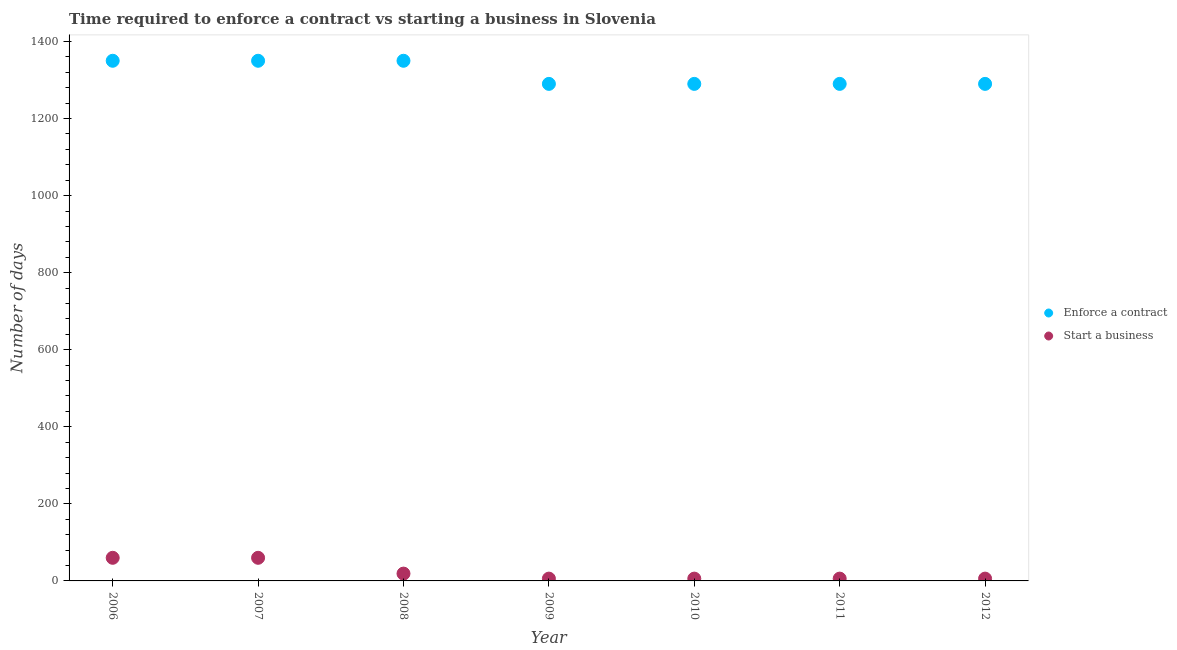How many different coloured dotlines are there?
Your answer should be compact. 2. What is the number of days to enforece a contract in 2010?
Provide a short and direct response. 1290. Across all years, what is the maximum number of days to enforece a contract?
Make the answer very short. 1350. Across all years, what is the minimum number of days to start a business?
Offer a very short reply. 6. In which year was the number of days to enforece a contract maximum?
Make the answer very short. 2006. In which year was the number of days to start a business minimum?
Offer a terse response. 2009. What is the total number of days to start a business in the graph?
Keep it short and to the point. 163. What is the difference between the number of days to enforece a contract in 2011 and the number of days to start a business in 2012?
Your response must be concise. 1284. What is the average number of days to start a business per year?
Your answer should be very brief. 23.29. In the year 2010, what is the difference between the number of days to enforece a contract and number of days to start a business?
Keep it short and to the point. 1284. In how many years, is the number of days to start a business greater than 360 days?
Provide a short and direct response. 0. What is the ratio of the number of days to enforece a contract in 2007 to that in 2011?
Give a very brief answer. 1.05. Is the number of days to enforece a contract in 2010 less than that in 2011?
Your answer should be compact. No. What is the difference between the highest and the second highest number of days to enforece a contract?
Offer a terse response. 0. What is the difference between the highest and the lowest number of days to enforece a contract?
Keep it short and to the point. 60. Does the number of days to enforece a contract monotonically increase over the years?
Offer a terse response. No. Is the number of days to enforece a contract strictly less than the number of days to start a business over the years?
Provide a succinct answer. No. What is the difference between two consecutive major ticks on the Y-axis?
Your response must be concise. 200. Are the values on the major ticks of Y-axis written in scientific E-notation?
Give a very brief answer. No. Does the graph contain any zero values?
Provide a short and direct response. No. Where does the legend appear in the graph?
Your response must be concise. Center right. What is the title of the graph?
Offer a very short reply. Time required to enforce a contract vs starting a business in Slovenia. What is the label or title of the X-axis?
Give a very brief answer. Year. What is the label or title of the Y-axis?
Offer a very short reply. Number of days. What is the Number of days in Enforce a contract in 2006?
Your answer should be very brief. 1350. What is the Number of days in Start a business in 2006?
Provide a succinct answer. 60. What is the Number of days in Enforce a contract in 2007?
Provide a short and direct response. 1350. What is the Number of days of Start a business in 2007?
Your response must be concise. 60. What is the Number of days in Enforce a contract in 2008?
Your answer should be compact. 1350. What is the Number of days of Enforce a contract in 2009?
Your answer should be very brief. 1290. What is the Number of days of Start a business in 2009?
Your answer should be very brief. 6. What is the Number of days in Enforce a contract in 2010?
Ensure brevity in your answer.  1290. What is the Number of days of Start a business in 2010?
Your answer should be very brief. 6. What is the Number of days in Enforce a contract in 2011?
Keep it short and to the point. 1290. What is the Number of days in Start a business in 2011?
Keep it short and to the point. 6. What is the Number of days of Enforce a contract in 2012?
Make the answer very short. 1290. What is the Number of days in Start a business in 2012?
Keep it short and to the point. 6. Across all years, what is the maximum Number of days of Enforce a contract?
Provide a succinct answer. 1350. Across all years, what is the maximum Number of days of Start a business?
Give a very brief answer. 60. Across all years, what is the minimum Number of days in Enforce a contract?
Your answer should be very brief. 1290. Across all years, what is the minimum Number of days of Start a business?
Ensure brevity in your answer.  6. What is the total Number of days in Enforce a contract in the graph?
Your answer should be very brief. 9210. What is the total Number of days of Start a business in the graph?
Keep it short and to the point. 163. What is the difference between the Number of days in Enforce a contract in 2006 and that in 2008?
Your response must be concise. 0. What is the difference between the Number of days of Start a business in 2006 and that in 2008?
Offer a very short reply. 41. What is the difference between the Number of days of Enforce a contract in 2006 and that in 2009?
Give a very brief answer. 60. What is the difference between the Number of days in Enforce a contract in 2006 and that in 2010?
Give a very brief answer. 60. What is the difference between the Number of days in Start a business in 2006 and that in 2012?
Keep it short and to the point. 54. What is the difference between the Number of days in Start a business in 2007 and that in 2008?
Offer a terse response. 41. What is the difference between the Number of days of Start a business in 2007 and that in 2009?
Provide a succinct answer. 54. What is the difference between the Number of days in Start a business in 2007 and that in 2011?
Provide a succinct answer. 54. What is the difference between the Number of days in Start a business in 2007 and that in 2012?
Give a very brief answer. 54. What is the difference between the Number of days in Enforce a contract in 2008 and that in 2009?
Make the answer very short. 60. What is the difference between the Number of days in Start a business in 2008 and that in 2011?
Keep it short and to the point. 13. What is the difference between the Number of days of Enforce a contract in 2008 and that in 2012?
Provide a succinct answer. 60. What is the difference between the Number of days in Start a business in 2008 and that in 2012?
Provide a short and direct response. 13. What is the difference between the Number of days in Enforce a contract in 2009 and that in 2010?
Ensure brevity in your answer.  0. What is the difference between the Number of days of Start a business in 2009 and that in 2011?
Keep it short and to the point. 0. What is the difference between the Number of days of Start a business in 2009 and that in 2012?
Your answer should be compact. 0. What is the difference between the Number of days in Start a business in 2010 and that in 2011?
Provide a succinct answer. 0. What is the difference between the Number of days of Enforce a contract in 2010 and that in 2012?
Give a very brief answer. 0. What is the difference between the Number of days in Enforce a contract in 2011 and that in 2012?
Ensure brevity in your answer.  0. What is the difference between the Number of days in Enforce a contract in 2006 and the Number of days in Start a business in 2007?
Make the answer very short. 1290. What is the difference between the Number of days of Enforce a contract in 2006 and the Number of days of Start a business in 2008?
Your answer should be compact. 1331. What is the difference between the Number of days of Enforce a contract in 2006 and the Number of days of Start a business in 2009?
Give a very brief answer. 1344. What is the difference between the Number of days in Enforce a contract in 2006 and the Number of days in Start a business in 2010?
Offer a very short reply. 1344. What is the difference between the Number of days in Enforce a contract in 2006 and the Number of days in Start a business in 2011?
Keep it short and to the point. 1344. What is the difference between the Number of days of Enforce a contract in 2006 and the Number of days of Start a business in 2012?
Offer a terse response. 1344. What is the difference between the Number of days of Enforce a contract in 2007 and the Number of days of Start a business in 2008?
Offer a terse response. 1331. What is the difference between the Number of days of Enforce a contract in 2007 and the Number of days of Start a business in 2009?
Provide a short and direct response. 1344. What is the difference between the Number of days in Enforce a contract in 2007 and the Number of days in Start a business in 2010?
Provide a short and direct response. 1344. What is the difference between the Number of days of Enforce a contract in 2007 and the Number of days of Start a business in 2011?
Provide a succinct answer. 1344. What is the difference between the Number of days in Enforce a contract in 2007 and the Number of days in Start a business in 2012?
Your response must be concise. 1344. What is the difference between the Number of days in Enforce a contract in 2008 and the Number of days in Start a business in 2009?
Make the answer very short. 1344. What is the difference between the Number of days of Enforce a contract in 2008 and the Number of days of Start a business in 2010?
Provide a short and direct response. 1344. What is the difference between the Number of days in Enforce a contract in 2008 and the Number of days in Start a business in 2011?
Give a very brief answer. 1344. What is the difference between the Number of days of Enforce a contract in 2008 and the Number of days of Start a business in 2012?
Your response must be concise. 1344. What is the difference between the Number of days in Enforce a contract in 2009 and the Number of days in Start a business in 2010?
Offer a terse response. 1284. What is the difference between the Number of days of Enforce a contract in 2009 and the Number of days of Start a business in 2011?
Provide a succinct answer. 1284. What is the difference between the Number of days in Enforce a contract in 2009 and the Number of days in Start a business in 2012?
Your answer should be very brief. 1284. What is the difference between the Number of days of Enforce a contract in 2010 and the Number of days of Start a business in 2011?
Give a very brief answer. 1284. What is the difference between the Number of days of Enforce a contract in 2010 and the Number of days of Start a business in 2012?
Give a very brief answer. 1284. What is the difference between the Number of days in Enforce a contract in 2011 and the Number of days in Start a business in 2012?
Provide a succinct answer. 1284. What is the average Number of days in Enforce a contract per year?
Make the answer very short. 1315.71. What is the average Number of days of Start a business per year?
Give a very brief answer. 23.29. In the year 2006, what is the difference between the Number of days in Enforce a contract and Number of days in Start a business?
Provide a short and direct response. 1290. In the year 2007, what is the difference between the Number of days in Enforce a contract and Number of days in Start a business?
Keep it short and to the point. 1290. In the year 2008, what is the difference between the Number of days of Enforce a contract and Number of days of Start a business?
Offer a terse response. 1331. In the year 2009, what is the difference between the Number of days of Enforce a contract and Number of days of Start a business?
Provide a succinct answer. 1284. In the year 2010, what is the difference between the Number of days of Enforce a contract and Number of days of Start a business?
Make the answer very short. 1284. In the year 2011, what is the difference between the Number of days in Enforce a contract and Number of days in Start a business?
Your response must be concise. 1284. In the year 2012, what is the difference between the Number of days in Enforce a contract and Number of days in Start a business?
Offer a very short reply. 1284. What is the ratio of the Number of days in Start a business in 2006 to that in 2007?
Give a very brief answer. 1. What is the ratio of the Number of days in Start a business in 2006 to that in 2008?
Keep it short and to the point. 3.16. What is the ratio of the Number of days of Enforce a contract in 2006 to that in 2009?
Offer a very short reply. 1.05. What is the ratio of the Number of days in Enforce a contract in 2006 to that in 2010?
Your response must be concise. 1.05. What is the ratio of the Number of days in Enforce a contract in 2006 to that in 2011?
Give a very brief answer. 1.05. What is the ratio of the Number of days of Start a business in 2006 to that in 2011?
Provide a succinct answer. 10. What is the ratio of the Number of days of Enforce a contract in 2006 to that in 2012?
Your answer should be compact. 1.05. What is the ratio of the Number of days in Start a business in 2006 to that in 2012?
Give a very brief answer. 10. What is the ratio of the Number of days in Start a business in 2007 to that in 2008?
Make the answer very short. 3.16. What is the ratio of the Number of days in Enforce a contract in 2007 to that in 2009?
Your answer should be very brief. 1.05. What is the ratio of the Number of days in Enforce a contract in 2007 to that in 2010?
Keep it short and to the point. 1.05. What is the ratio of the Number of days of Enforce a contract in 2007 to that in 2011?
Offer a very short reply. 1.05. What is the ratio of the Number of days of Start a business in 2007 to that in 2011?
Make the answer very short. 10. What is the ratio of the Number of days of Enforce a contract in 2007 to that in 2012?
Provide a short and direct response. 1.05. What is the ratio of the Number of days in Start a business in 2007 to that in 2012?
Offer a terse response. 10. What is the ratio of the Number of days in Enforce a contract in 2008 to that in 2009?
Offer a very short reply. 1.05. What is the ratio of the Number of days in Start a business in 2008 to that in 2009?
Your response must be concise. 3.17. What is the ratio of the Number of days of Enforce a contract in 2008 to that in 2010?
Your response must be concise. 1.05. What is the ratio of the Number of days in Start a business in 2008 to that in 2010?
Give a very brief answer. 3.17. What is the ratio of the Number of days of Enforce a contract in 2008 to that in 2011?
Offer a very short reply. 1.05. What is the ratio of the Number of days of Start a business in 2008 to that in 2011?
Provide a short and direct response. 3.17. What is the ratio of the Number of days in Enforce a contract in 2008 to that in 2012?
Ensure brevity in your answer.  1.05. What is the ratio of the Number of days of Start a business in 2008 to that in 2012?
Your answer should be compact. 3.17. What is the ratio of the Number of days in Enforce a contract in 2009 to that in 2010?
Give a very brief answer. 1. What is the ratio of the Number of days of Start a business in 2009 to that in 2010?
Make the answer very short. 1. What is the ratio of the Number of days of Enforce a contract in 2010 to that in 2011?
Your answer should be compact. 1. 